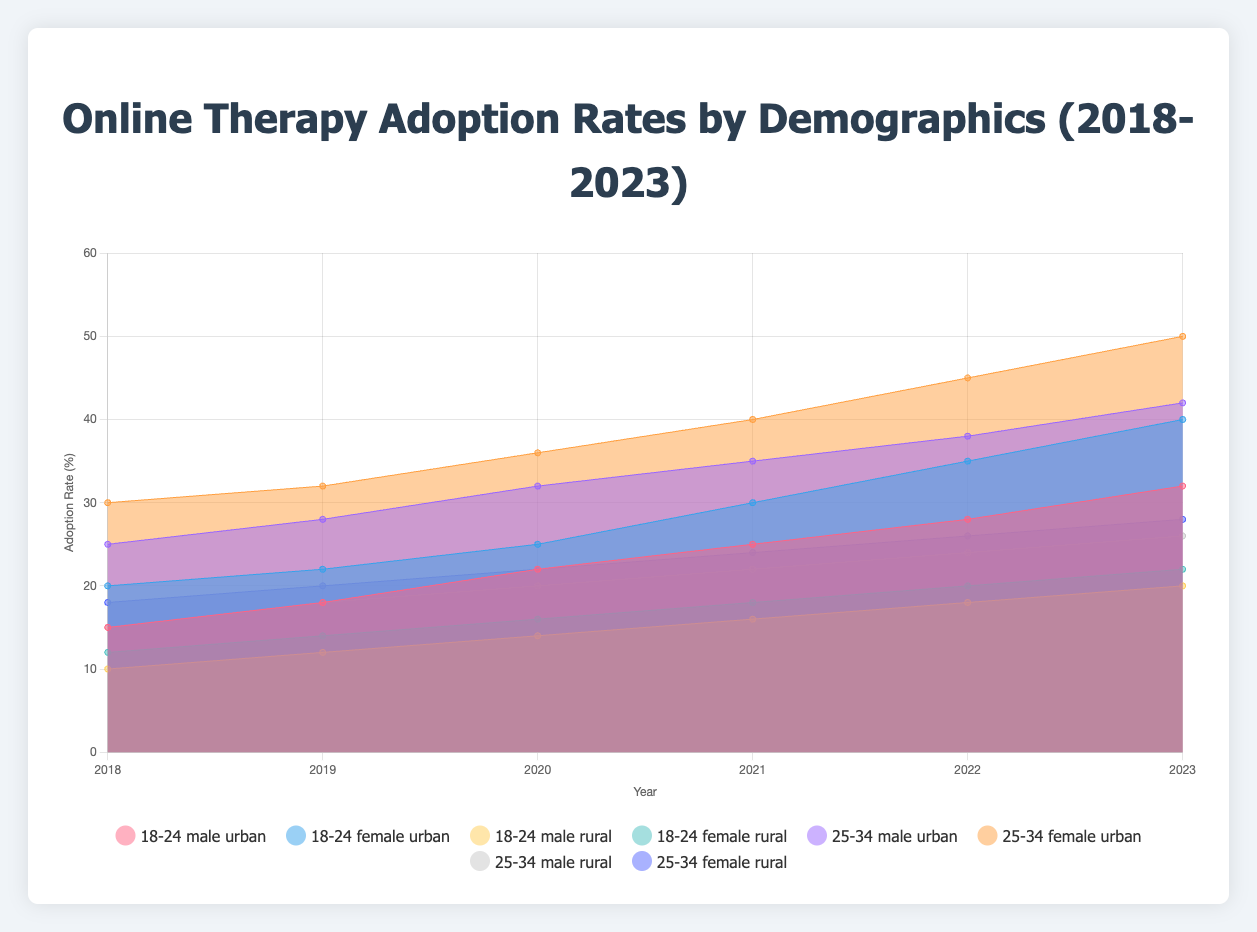What years are covered in the figure? The figure's x-axis shows the years marked at intervals, covering a range from the earliest to the latest year included. Observing these years will provide the range of years displayed.
Answer: 2018-2023 Which age group and demographics had the highest adoption rate in 2023? To find this, look at the point on the y-axis with the highest value for the year 2023 and identify the corresponding demographics (age group, gender, location) from the legend.
Answer: 25-34 female urban How did the adoption rate change for 18-24 female in rural areas from 2018 to 2023? To see the change, locate the data points for 18-24 female in rural areas for the years 2018 and 2023 on the y-axis. Subtract the 2018 value from the 2023 value to find the change.
Answer: Increase by 10 (from 12 to 22) Which year saw the highest overall adoption rate for the 25-34 male urban demographic? Check the line corresponding to 25-34 male urban and find the year where the y-axis value is at its highest.
Answer: 2023 Compare the adoption rates for 18-24 males in urban areas between 2019 and 2023. Which year had a higher rate? Identify the data points for 18-24 male urban for the years 2019 and 2023 on the y-axis. Compare the values and see which year is higher.
Answer: 2023 Which age group and gender had a consistent increase in adoption rates in urban areas across the years? Look at the lines for urban areas and check the trend for each age group and gender. A consistent increase will have a line that steadily rises from 2018 to 2023.
Answer: 25-34 female Calculate the average adoption rate for 25-34 males in rural areas across all years. Sum the adoption rates for 25-34 males in rural areas for each year and divide by the number of years (6) to get the average.
Answer: 21 What is the total increase in adoption rates for 18-24 females in urban areas from 2018 to 2023? Subtract the 2018 adoption rate from the 2023 rate for 18-24 females in urban areas to get the increase.
Answer: 20 (from 20 to 40) What is the difference in the adoption rate for 25-34 females in urban vs. rural areas in 2021? Identify the adoption rates for 25-34 females in both urban and rural areas in 2021 on the y-axis and subtract the rural rate from the urban rate.
Answer: 16 (40 - 24) 